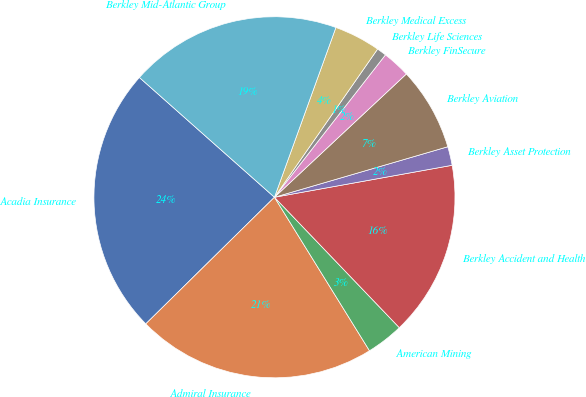Convert chart to OTSL. <chart><loc_0><loc_0><loc_500><loc_500><pie_chart><fcel>Acadia Insurance<fcel>Admiral Insurance<fcel>American Mining<fcel>Berkley Accident and Health<fcel>Berkley Asset Protection<fcel>Berkley Aviation<fcel>Berkley FinSecure<fcel>Berkley Life Sciences<fcel>Berkley Medical Excess<fcel>Berkley Mid-Atlantic Group<nl><fcel>23.92%<fcel>21.45%<fcel>3.33%<fcel>15.68%<fcel>1.68%<fcel>7.45%<fcel>2.5%<fcel>0.86%<fcel>4.15%<fcel>18.98%<nl></chart> 